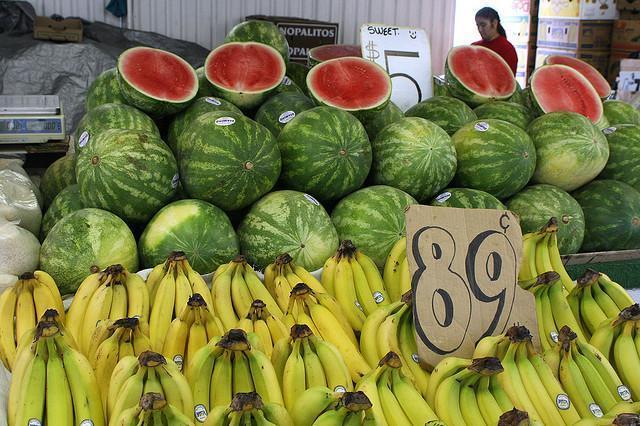How many bananas are there?
Give a very brief answer. 13. How many dark umbrellas are there?
Give a very brief answer. 0. 